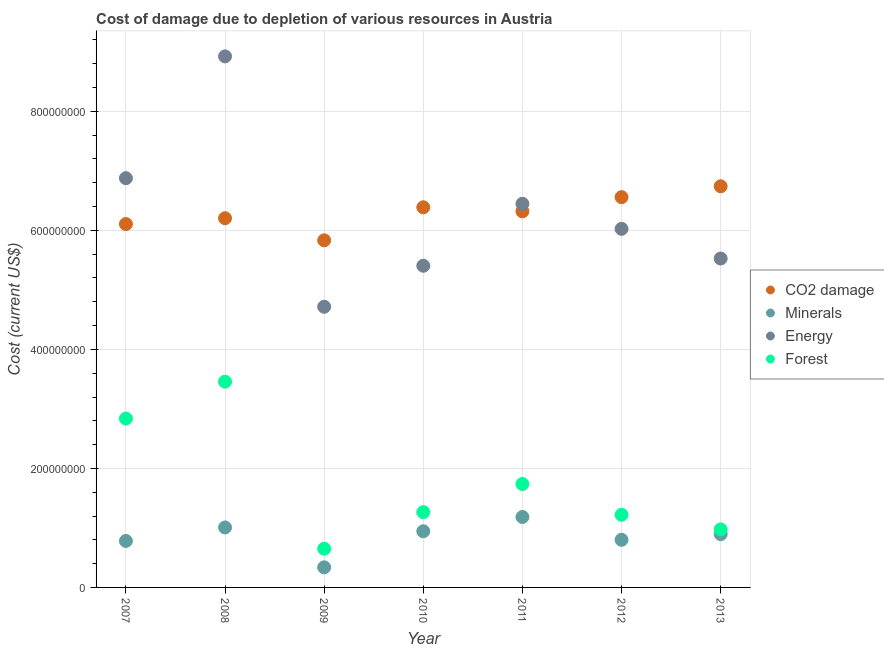What is the cost of damage due to depletion of energy in 2007?
Make the answer very short. 6.88e+08. Across all years, what is the maximum cost of damage due to depletion of minerals?
Your answer should be very brief. 1.18e+08. Across all years, what is the minimum cost of damage due to depletion of minerals?
Your answer should be very brief. 3.38e+07. What is the total cost of damage due to depletion of minerals in the graph?
Provide a short and direct response. 5.95e+08. What is the difference between the cost of damage due to depletion of energy in 2008 and that in 2009?
Provide a short and direct response. 4.21e+08. What is the difference between the cost of damage due to depletion of coal in 2011 and the cost of damage due to depletion of minerals in 2007?
Offer a very short reply. 5.54e+08. What is the average cost of damage due to depletion of minerals per year?
Give a very brief answer. 8.50e+07. In the year 2013, what is the difference between the cost of damage due to depletion of energy and cost of damage due to depletion of minerals?
Your answer should be very brief. 4.63e+08. In how many years, is the cost of damage due to depletion of coal greater than 160000000 US$?
Offer a very short reply. 7. What is the ratio of the cost of damage due to depletion of energy in 2007 to that in 2010?
Give a very brief answer. 1.27. What is the difference between the highest and the second highest cost of damage due to depletion of energy?
Your answer should be very brief. 2.05e+08. What is the difference between the highest and the lowest cost of damage due to depletion of forests?
Offer a terse response. 2.81e+08. In how many years, is the cost of damage due to depletion of coal greater than the average cost of damage due to depletion of coal taken over all years?
Give a very brief answer. 4. Is it the case that in every year, the sum of the cost of damage due to depletion of minerals and cost of damage due to depletion of energy is greater than the sum of cost of damage due to depletion of forests and cost of damage due to depletion of coal?
Give a very brief answer. Yes. Does the cost of damage due to depletion of minerals monotonically increase over the years?
Offer a terse response. No. Is the cost of damage due to depletion of forests strictly greater than the cost of damage due to depletion of minerals over the years?
Provide a short and direct response. Yes. Is the cost of damage due to depletion of coal strictly less than the cost of damage due to depletion of forests over the years?
Provide a short and direct response. No. How many dotlines are there?
Your answer should be very brief. 4. What is the difference between two consecutive major ticks on the Y-axis?
Keep it short and to the point. 2.00e+08. Does the graph contain grids?
Ensure brevity in your answer.  Yes. What is the title of the graph?
Your response must be concise. Cost of damage due to depletion of various resources in Austria . Does "Permanent crop land" appear as one of the legend labels in the graph?
Make the answer very short. No. What is the label or title of the X-axis?
Offer a terse response. Year. What is the label or title of the Y-axis?
Your response must be concise. Cost (current US$). What is the Cost (current US$) in CO2 damage in 2007?
Your answer should be compact. 6.11e+08. What is the Cost (current US$) in Minerals in 2007?
Make the answer very short. 7.81e+07. What is the Cost (current US$) in Energy in 2007?
Your answer should be very brief. 6.88e+08. What is the Cost (current US$) of Forest in 2007?
Give a very brief answer. 2.84e+08. What is the Cost (current US$) of CO2 damage in 2008?
Your answer should be very brief. 6.20e+08. What is the Cost (current US$) in Minerals in 2008?
Ensure brevity in your answer.  1.01e+08. What is the Cost (current US$) of Energy in 2008?
Ensure brevity in your answer.  8.92e+08. What is the Cost (current US$) in Forest in 2008?
Give a very brief answer. 3.46e+08. What is the Cost (current US$) in CO2 damage in 2009?
Give a very brief answer. 5.83e+08. What is the Cost (current US$) of Minerals in 2009?
Your answer should be compact. 3.38e+07. What is the Cost (current US$) in Energy in 2009?
Keep it short and to the point. 4.72e+08. What is the Cost (current US$) of Forest in 2009?
Your answer should be compact. 6.51e+07. What is the Cost (current US$) of CO2 damage in 2010?
Offer a very short reply. 6.39e+08. What is the Cost (current US$) of Minerals in 2010?
Your answer should be very brief. 9.44e+07. What is the Cost (current US$) of Energy in 2010?
Your answer should be very brief. 5.41e+08. What is the Cost (current US$) in Forest in 2010?
Keep it short and to the point. 1.27e+08. What is the Cost (current US$) of CO2 damage in 2011?
Provide a short and direct response. 6.32e+08. What is the Cost (current US$) in Minerals in 2011?
Offer a very short reply. 1.18e+08. What is the Cost (current US$) in Energy in 2011?
Provide a short and direct response. 6.45e+08. What is the Cost (current US$) of Forest in 2011?
Keep it short and to the point. 1.74e+08. What is the Cost (current US$) in CO2 damage in 2012?
Offer a very short reply. 6.56e+08. What is the Cost (current US$) in Minerals in 2012?
Keep it short and to the point. 8.00e+07. What is the Cost (current US$) of Energy in 2012?
Your answer should be compact. 6.03e+08. What is the Cost (current US$) of Forest in 2012?
Your answer should be compact. 1.22e+08. What is the Cost (current US$) in CO2 damage in 2013?
Make the answer very short. 6.74e+08. What is the Cost (current US$) of Minerals in 2013?
Your response must be concise. 8.96e+07. What is the Cost (current US$) in Energy in 2013?
Ensure brevity in your answer.  5.53e+08. What is the Cost (current US$) of Forest in 2013?
Keep it short and to the point. 9.76e+07. Across all years, what is the maximum Cost (current US$) in CO2 damage?
Give a very brief answer. 6.74e+08. Across all years, what is the maximum Cost (current US$) in Minerals?
Provide a short and direct response. 1.18e+08. Across all years, what is the maximum Cost (current US$) of Energy?
Your answer should be compact. 8.92e+08. Across all years, what is the maximum Cost (current US$) of Forest?
Provide a succinct answer. 3.46e+08. Across all years, what is the minimum Cost (current US$) in CO2 damage?
Your response must be concise. 5.83e+08. Across all years, what is the minimum Cost (current US$) of Minerals?
Provide a succinct answer. 3.38e+07. Across all years, what is the minimum Cost (current US$) in Energy?
Make the answer very short. 4.72e+08. Across all years, what is the minimum Cost (current US$) of Forest?
Provide a succinct answer. 6.51e+07. What is the total Cost (current US$) in CO2 damage in the graph?
Provide a short and direct response. 4.42e+09. What is the total Cost (current US$) of Minerals in the graph?
Offer a very short reply. 5.95e+08. What is the total Cost (current US$) of Energy in the graph?
Ensure brevity in your answer.  4.39e+09. What is the total Cost (current US$) of Forest in the graph?
Give a very brief answer. 1.21e+09. What is the difference between the Cost (current US$) in CO2 damage in 2007 and that in 2008?
Your answer should be very brief. -9.76e+06. What is the difference between the Cost (current US$) in Minerals in 2007 and that in 2008?
Make the answer very short. -2.27e+07. What is the difference between the Cost (current US$) of Energy in 2007 and that in 2008?
Give a very brief answer. -2.05e+08. What is the difference between the Cost (current US$) of Forest in 2007 and that in 2008?
Keep it short and to the point. -6.19e+07. What is the difference between the Cost (current US$) of CO2 damage in 2007 and that in 2009?
Provide a succinct answer. 2.74e+07. What is the difference between the Cost (current US$) in Minerals in 2007 and that in 2009?
Offer a terse response. 4.43e+07. What is the difference between the Cost (current US$) of Energy in 2007 and that in 2009?
Ensure brevity in your answer.  2.16e+08. What is the difference between the Cost (current US$) in Forest in 2007 and that in 2009?
Your answer should be compact. 2.19e+08. What is the difference between the Cost (current US$) in CO2 damage in 2007 and that in 2010?
Your answer should be compact. -2.82e+07. What is the difference between the Cost (current US$) of Minerals in 2007 and that in 2010?
Give a very brief answer. -1.63e+07. What is the difference between the Cost (current US$) in Energy in 2007 and that in 2010?
Ensure brevity in your answer.  1.47e+08. What is the difference between the Cost (current US$) in Forest in 2007 and that in 2010?
Provide a short and direct response. 1.57e+08. What is the difference between the Cost (current US$) in CO2 damage in 2007 and that in 2011?
Make the answer very short. -2.13e+07. What is the difference between the Cost (current US$) of Minerals in 2007 and that in 2011?
Offer a terse response. -4.03e+07. What is the difference between the Cost (current US$) in Energy in 2007 and that in 2011?
Your answer should be compact. 4.31e+07. What is the difference between the Cost (current US$) in Forest in 2007 and that in 2011?
Offer a very short reply. 1.10e+08. What is the difference between the Cost (current US$) in CO2 damage in 2007 and that in 2012?
Make the answer very short. -4.52e+07. What is the difference between the Cost (current US$) of Minerals in 2007 and that in 2012?
Ensure brevity in your answer.  -1.89e+06. What is the difference between the Cost (current US$) of Energy in 2007 and that in 2012?
Offer a very short reply. 8.51e+07. What is the difference between the Cost (current US$) of Forest in 2007 and that in 2012?
Offer a very short reply. 1.62e+08. What is the difference between the Cost (current US$) of CO2 damage in 2007 and that in 2013?
Your response must be concise. -6.35e+07. What is the difference between the Cost (current US$) of Minerals in 2007 and that in 2013?
Ensure brevity in your answer.  -1.14e+07. What is the difference between the Cost (current US$) of Energy in 2007 and that in 2013?
Your answer should be very brief. 1.35e+08. What is the difference between the Cost (current US$) in Forest in 2007 and that in 2013?
Make the answer very short. 1.86e+08. What is the difference between the Cost (current US$) of CO2 damage in 2008 and that in 2009?
Give a very brief answer. 3.71e+07. What is the difference between the Cost (current US$) of Minerals in 2008 and that in 2009?
Give a very brief answer. 6.70e+07. What is the difference between the Cost (current US$) of Energy in 2008 and that in 2009?
Give a very brief answer. 4.21e+08. What is the difference between the Cost (current US$) of Forest in 2008 and that in 2009?
Provide a succinct answer. 2.81e+08. What is the difference between the Cost (current US$) of CO2 damage in 2008 and that in 2010?
Your response must be concise. -1.84e+07. What is the difference between the Cost (current US$) in Minerals in 2008 and that in 2010?
Offer a terse response. 6.42e+06. What is the difference between the Cost (current US$) of Energy in 2008 and that in 2010?
Offer a terse response. 3.52e+08. What is the difference between the Cost (current US$) in Forest in 2008 and that in 2010?
Make the answer very short. 2.19e+08. What is the difference between the Cost (current US$) in CO2 damage in 2008 and that in 2011?
Your response must be concise. -1.16e+07. What is the difference between the Cost (current US$) in Minerals in 2008 and that in 2011?
Your answer should be very brief. -1.76e+07. What is the difference between the Cost (current US$) in Energy in 2008 and that in 2011?
Your response must be concise. 2.48e+08. What is the difference between the Cost (current US$) in Forest in 2008 and that in 2011?
Make the answer very short. 1.72e+08. What is the difference between the Cost (current US$) in CO2 damage in 2008 and that in 2012?
Provide a succinct answer. -3.54e+07. What is the difference between the Cost (current US$) of Minerals in 2008 and that in 2012?
Provide a succinct answer. 2.08e+07. What is the difference between the Cost (current US$) of Energy in 2008 and that in 2012?
Give a very brief answer. 2.90e+08. What is the difference between the Cost (current US$) of Forest in 2008 and that in 2012?
Give a very brief answer. 2.24e+08. What is the difference between the Cost (current US$) of CO2 damage in 2008 and that in 2013?
Your answer should be very brief. -5.38e+07. What is the difference between the Cost (current US$) in Minerals in 2008 and that in 2013?
Offer a terse response. 1.12e+07. What is the difference between the Cost (current US$) of Energy in 2008 and that in 2013?
Offer a very short reply. 3.40e+08. What is the difference between the Cost (current US$) of Forest in 2008 and that in 2013?
Keep it short and to the point. 2.48e+08. What is the difference between the Cost (current US$) in CO2 damage in 2009 and that in 2010?
Your answer should be very brief. -5.55e+07. What is the difference between the Cost (current US$) in Minerals in 2009 and that in 2010?
Make the answer very short. -6.06e+07. What is the difference between the Cost (current US$) in Energy in 2009 and that in 2010?
Your answer should be very brief. -6.89e+07. What is the difference between the Cost (current US$) in Forest in 2009 and that in 2010?
Provide a short and direct response. -6.14e+07. What is the difference between the Cost (current US$) of CO2 damage in 2009 and that in 2011?
Give a very brief answer. -4.87e+07. What is the difference between the Cost (current US$) in Minerals in 2009 and that in 2011?
Make the answer very short. -8.46e+07. What is the difference between the Cost (current US$) in Energy in 2009 and that in 2011?
Make the answer very short. -1.73e+08. What is the difference between the Cost (current US$) in Forest in 2009 and that in 2011?
Give a very brief answer. -1.09e+08. What is the difference between the Cost (current US$) of CO2 damage in 2009 and that in 2012?
Your answer should be compact. -7.26e+07. What is the difference between the Cost (current US$) of Minerals in 2009 and that in 2012?
Your answer should be very brief. -4.62e+07. What is the difference between the Cost (current US$) of Energy in 2009 and that in 2012?
Keep it short and to the point. -1.31e+08. What is the difference between the Cost (current US$) in Forest in 2009 and that in 2012?
Your answer should be very brief. -5.70e+07. What is the difference between the Cost (current US$) of CO2 damage in 2009 and that in 2013?
Offer a terse response. -9.09e+07. What is the difference between the Cost (current US$) in Minerals in 2009 and that in 2013?
Give a very brief answer. -5.58e+07. What is the difference between the Cost (current US$) in Energy in 2009 and that in 2013?
Make the answer very short. -8.10e+07. What is the difference between the Cost (current US$) in Forest in 2009 and that in 2013?
Your answer should be compact. -3.25e+07. What is the difference between the Cost (current US$) in CO2 damage in 2010 and that in 2011?
Ensure brevity in your answer.  6.82e+06. What is the difference between the Cost (current US$) in Minerals in 2010 and that in 2011?
Make the answer very short. -2.40e+07. What is the difference between the Cost (current US$) in Energy in 2010 and that in 2011?
Give a very brief answer. -1.04e+08. What is the difference between the Cost (current US$) of Forest in 2010 and that in 2011?
Give a very brief answer. -4.73e+07. What is the difference between the Cost (current US$) of CO2 damage in 2010 and that in 2012?
Your answer should be very brief. -1.70e+07. What is the difference between the Cost (current US$) of Minerals in 2010 and that in 2012?
Your answer should be very brief. 1.44e+07. What is the difference between the Cost (current US$) of Energy in 2010 and that in 2012?
Provide a succinct answer. -6.20e+07. What is the difference between the Cost (current US$) of Forest in 2010 and that in 2012?
Offer a terse response. 4.48e+06. What is the difference between the Cost (current US$) in CO2 damage in 2010 and that in 2013?
Keep it short and to the point. -3.53e+07. What is the difference between the Cost (current US$) of Minerals in 2010 and that in 2013?
Ensure brevity in your answer.  4.80e+06. What is the difference between the Cost (current US$) in Energy in 2010 and that in 2013?
Offer a very short reply. -1.21e+07. What is the difference between the Cost (current US$) of Forest in 2010 and that in 2013?
Provide a short and direct response. 2.90e+07. What is the difference between the Cost (current US$) of CO2 damage in 2011 and that in 2012?
Your answer should be very brief. -2.39e+07. What is the difference between the Cost (current US$) in Minerals in 2011 and that in 2012?
Provide a short and direct response. 3.84e+07. What is the difference between the Cost (current US$) of Energy in 2011 and that in 2012?
Your response must be concise. 4.21e+07. What is the difference between the Cost (current US$) of Forest in 2011 and that in 2012?
Your answer should be very brief. 5.17e+07. What is the difference between the Cost (current US$) of CO2 damage in 2011 and that in 2013?
Provide a short and direct response. -4.22e+07. What is the difference between the Cost (current US$) in Minerals in 2011 and that in 2013?
Ensure brevity in your answer.  2.88e+07. What is the difference between the Cost (current US$) of Energy in 2011 and that in 2013?
Ensure brevity in your answer.  9.20e+07. What is the difference between the Cost (current US$) of Forest in 2011 and that in 2013?
Give a very brief answer. 7.62e+07. What is the difference between the Cost (current US$) of CO2 damage in 2012 and that in 2013?
Make the answer very short. -1.83e+07. What is the difference between the Cost (current US$) in Minerals in 2012 and that in 2013?
Offer a very short reply. -9.55e+06. What is the difference between the Cost (current US$) in Energy in 2012 and that in 2013?
Your answer should be compact. 4.99e+07. What is the difference between the Cost (current US$) of Forest in 2012 and that in 2013?
Provide a succinct answer. 2.45e+07. What is the difference between the Cost (current US$) in CO2 damage in 2007 and the Cost (current US$) in Minerals in 2008?
Keep it short and to the point. 5.10e+08. What is the difference between the Cost (current US$) of CO2 damage in 2007 and the Cost (current US$) of Energy in 2008?
Your answer should be very brief. -2.82e+08. What is the difference between the Cost (current US$) in CO2 damage in 2007 and the Cost (current US$) in Forest in 2008?
Your response must be concise. 2.65e+08. What is the difference between the Cost (current US$) in Minerals in 2007 and the Cost (current US$) in Energy in 2008?
Keep it short and to the point. -8.14e+08. What is the difference between the Cost (current US$) of Minerals in 2007 and the Cost (current US$) of Forest in 2008?
Your response must be concise. -2.68e+08. What is the difference between the Cost (current US$) of Energy in 2007 and the Cost (current US$) of Forest in 2008?
Provide a short and direct response. 3.42e+08. What is the difference between the Cost (current US$) in CO2 damage in 2007 and the Cost (current US$) in Minerals in 2009?
Offer a terse response. 5.77e+08. What is the difference between the Cost (current US$) of CO2 damage in 2007 and the Cost (current US$) of Energy in 2009?
Your answer should be compact. 1.39e+08. What is the difference between the Cost (current US$) in CO2 damage in 2007 and the Cost (current US$) in Forest in 2009?
Offer a very short reply. 5.46e+08. What is the difference between the Cost (current US$) of Minerals in 2007 and the Cost (current US$) of Energy in 2009?
Keep it short and to the point. -3.94e+08. What is the difference between the Cost (current US$) of Minerals in 2007 and the Cost (current US$) of Forest in 2009?
Your answer should be very brief. 1.30e+07. What is the difference between the Cost (current US$) in Energy in 2007 and the Cost (current US$) in Forest in 2009?
Provide a succinct answer. 6.23e+08. What is the difference between the Cost (current US$) in CO2 damage in 2007 and the Cost (current US$) in Minerals in 2010?
Keep it short and to the point. 5.16e+08. What is the difference between the Cost (current US$) in CO2 damage in 2007 and the Cost (current US$) in Energy in 2010?
Keep it short and to the point. 7.01e+07. What is the difference between the Cost (current US$) of CO2 damage in 2007 and the Cost (current US$) of Forest in 2010?
Your response must be concise. 4.84e+08. What is the difference between the Cost (current US$) of Minerals in 2007 and the Cost (current US$) of Energy in 2010?
Provide a short and direct response. -4.62e+08. What is the difference between the Cost (current US$) in Minerals in 2007 and the Cost (current US$) in Forest in 2010?
Make the answer very short. -4.84e+07. What is the difference between the Cost (current US$) in Energy in 2007 and the Cost (current US$) in Forest in 2010?
Provide a succinct answer. 5.61e+08. What is the difference between the Cost (current US$) of CO2 damage in 2007 and the Cost (current US$) of Minerals in 2011?
Your answer should be very brief. 4.92e+08. What is the difference between the Cost (current US$) in CO2 damage in 2007 and the Cost (current US$) in Energy in 2011?
Your answer should be very brief. -3.40e+07. What is the difference between the Cost (current US$) in CO2 damage in 2007 and the Cost (current US$) in Forest in 2011?
Offer a terse response. 4.37e+08. What is the difference between the Cost (current US$) in Minerals in 2007 and the Cost (current US$) in Energy in 2011?
Your answer should be compact. -5.67e+08. What is the difference between the Cost (current US$) of Minerals in 2007 and the Cost (current US$) of Forest in 2011?
Your answer should be very brief. -9.57e+07. What is the difference between the Cost (current US$) of Energy in 2007 and the Cost (current US$) of Forest in 2011?
Ensure brevity in your answer.  5.14e+08. What is the difference between the Cost (current US$) in CO2 damage in 2007 and the Cost (current US$) in Minerals in 2012?
Keep it short and to the point. 5.31e+08. What is the difference between the Cost (current US$) in CO2 damage in 2007 and the Cost (current US$) in Energy in 2012?
Provide a short and direct response. 8.07e+06. What is the difference between the Cost (current US$) of CO2 damage in 2007 and the Cost (current US$) of Forest in 2012?
Provide a short and direct response. 4.89e+08. What is the difference between the Cost (current US$) in Minerals in 2007 and the Cost (current US$) in Energy in 2012?
Keep it short and to the point. -5.24e+08. What is the difference between the Cost (current US$) of Minerals in 2007 and the Cost (current US$) of Forest in 2012?
Offer a very short reply. -4.39e+07. What is the difference between the Cost (current US$) of Energy in 2007 and the Cost (current US$) of Forest in 2012?
Your answer should be compact. 5.66e+08. What is the difference between the Cost (current US$) in CO2 damage in 2007 and the Cost (current US$) in Minerals in 2013?
Provide a succinct answer. 5.21e+08. What is the difference between the Cost (current US$) in CO2 damage in 2007 and the Cost (current US$) in Energy in 2013?
Provide a succinct answer. 5.80e+07. What is the difference between the Cost (current US$) in CO2 damage in 2007 and the Cost (current US$) in Forest in 2013?
Make the answer very short. 5.13e+08. What is the difference between the Cost (current US$) of Minerals in 2007 and the Cost (current US$) of Energy in 2013?
Ensure brevity in your answer.  -4.75e+08. What is the difference between the Cost (current US$) of Minerals in 2007 and the Cost (current US$) of Forest in 2013?
Make the answer very short. -1.94e+07. What is the difference between the Cost (current US$) of Energy in 2007 and the Cost (current US$) of Forest in 2013?
Give a very brief answer. 5.90e+08. What is the difference between the Cost (current US$) of CO2 damage in 2008 and the Cost (current US$) of Minerals in 2009?
Provide a short and direct response. 5.87e+08. What is the difference between the Cost (current US$) in CO2 damage in 2008 and the Cost (current US$) in Energy in 2009?
Your answer should be compact. 1.49e+08. What is the difference between the Cost (current US$) in CO2 damage in 2008 and the Cost (current US$) in Forest in 2009?
Your answer should be compact. 5.55e+08. What is the difference between the Cost (current US$) in Minerals in 2008 and the Cost (current US$) in Energy in 2009?
Your response must be concise. -3.71e+08. What is the difference between the Cost (current US$) of Minerals in 2008 and the Cost (current US$) of Forest in 2009?
Offer a terse response. 3.57e+07. What is the difference between the Cost (current US$) in Energy in 2008 and the Cost (current US$) in Forest in 2009?
Ensure brevity in your answer.  8.27e+08. What is the difference between the Cost (current US$) of CO2 damage in 2008 and the Cost (current US$) of Minerals in 2010?
Provide a short and direct response. 5.26e+08. What is the difference between the Cost (current US$) of CO2 damage in 2008 and the Cost (current US$) of Energy in 2010?
Provide a short and direct response. 7.99e+07. What is the difference between the Cost (current US$) of CO2 damage in 2008 and the Cost (current US$) of Forest in 2010?
Keep it short and to the point. 4.94e+08. What is the difference between the Cost (current US$) in Minerals in 2008 and the Cost (current US$) in Energy in 2010?
Make the answer very short. -4.40e+08. What is the difference between the Cost (current US$) of Minerals in 2008 and the Cost (current US$) of Forest in 2010?
Provide a succinct answer. -2.57e+07. What is the difference between the Cost (current US$) of Energy in 2008 and the Cost (current US$) of Forest in 2010?
Provide a succinct answer. 7.66e+08. What is the difference between the Cost (current US$) in CO2 damage in 2008 and the Cost (current US$) in Minerals in 2011?
Provide a succinct answer. 5.02e+08. What is the difference between the Cost (current US$) in CO2 damage in 2008 and the Cost (current US$) in Energy in 2011?
Ensure brevity in your answer.  -2.42e+07. What is the difference between the Cost (current US$) of CO2 damage in 2008 and the Cost (current US$) of Forest in 2011?
Make the answer very short. 4.47e+08. What is the difference between the Cost (current US$) in Minerals in 2008 and the Cost (current US$) in Energy in 2011?
Ensure brevity in your answer.  -5.44e+08. What is the difference between the Cost (current US$) in Minerals in 2008 and the Cost (current US$) in Forest in 2011?
Give a very brief answer. -7.30e+07. What is the difference between the Cost (current US$) in Energy in 2008 and the Cost (current US$) in Forest in 2011?
Offer a terse response. 7.19e+08. What is the difference between the Cost (current US$) in CO2 damage in 2008 and the Cost (current US$) in Minerals in 2012?
Your answer should be very brief. 5.40e+08. What is the difference between the Cost (current US$) of CO2 damage in 2008 and the Cost (current US$) of Energy in 2012?
Your response must be concise. 1.78e+07. What is the difference between the Cost (current US$) of CO2 damage in 2008 and the Cost (current US$) of Forest in 2012?
Provide a succinct answer. 4.98e+08. What is the difference between the Cost (current US$) in Minerals in 2008 and the Cost (current US$) in Energy in 2012?
Your answer should be compact. -5.02e+08. What is the difference between the Cost (current US$) of Minerals in 2008 and the Cost (current US$) of Forest in 2012?
Give a very brief answer. -2.13e+07. What is the difference between the Cost (current US$) in Energy in 2008 and the Cost (current US$) in Forest in 2012?
Provide a succinct answer. 7.70e+08. What is the difference between the Cost (current US$) in CO2 damage in 2008 and the Cost (current US$) in Minerals in 2013?
Provide a short and direct response. 5.31e+08. What is the difference between the Cost (current US$) of CO2 damage in 2008 and the Cost (current US$) of Energy in 2013?
Offer a very short reply. 6.77e+07. What is the difference between the Cost (current US$) in CO2 damage in 2008 and the Cost (current US$) in Forest in 2013?
Your answer should be very brief. 5.23e+08. What is the difference between the Cost (current US$) of Minerals in 2008 and the Cost (current US$) of Energy in 2013?
Offer a terse response. -4.52e+08. What is the difference between the Cost (current US$) of Minerals in 2008 and the Cost (current US$) of Forest in 2013?
Make the answer very short. 3.23e+06. What is the difference between the Cost (current US$) of Energy in 2008 and the Cost (current US$) of Forest in 2013?
Make the answer very short. 7.95e+08. What is the difference between the Cost (current US$) of CO2 damage in 2009 and the Cost (current US$) of Minerals in 2010?
Your response must be concise. 4.89e+08. What is the difference between the Cost (current US$) in CO2 damage in 2009 and the Cost (current US$) in Energy in 2010?
Ensure brevity in your answer.  4.27e+07. What is the difference between the Cost (current US$) in CO2 damage in 2009 and the Cost (current US$) in Forest in 2010?
Offer a terse response. 4.57e+08. What is the difference between the Cost (current US$) in Minerals in 2009 and the Cost (current US$) in Energy in 2010?
Provide a succinct answer. -5.07e+08. What is the difference between the Cost (current US$) of Minerals in 2009 and the Cost (current US$) of Forest in 2010?
Keep it short and to the point. -9.28e+07. What is the difference between the Cost (current US$) of Energy in 2009 and the Cost (current US$) of Forest in 2010?
Your answer should be very brief. 3.45e+08. What is the difference between the Cost (current US$) in CO2 damage in 2009 and the Cost (current US$) in Minerals in 2011?
Provide a succinct answer. 4.65e+08. What is the difference between the Cost (current US$) of CO2 damage in 2009 and the Cost (current US$) of Energy in 2011?
Your answer should be very brief. -6.14e+07. What is the difference between the Cost (current US$) in CO2 damage in 2009 and the Cost (current US$) in Forest in 2011?
Make the answer very short. 4.09e+08. What is the difference between the Cost (current US$) of Minerals in 2009 and the Cost (current US$) of Energy in 2011?
Give a very brief answer. -6.11e+08. What is the difference between the Cost (current US$) in Minerals in 2009 and the Cost (current US$) in Forest in 2011?
Your answer should be very brief. -1.40e+08. What is the difference between the Cost (current US$) in Energy in 2009 and the Cost (current US$) in Forest in 2011?
Offer a very short reply. 2.98e+08. What is the difference between the Cost (current US$) in CO2 damage in 2009 and the Cost (current US$) in Minerals in 2012?
Provide a short and direct response. 5.03e+08. What is the difference between the Cost (current US$) in CO2 damage in 2009 and the Cost (current US$) in Energy in 2012?
Keep it short and to the point. -1.93e+07. What is the difference between the Cost (current US$) in CO2 damage in 2009 and the Cost (current US$) in Forest in 2012?
Keep it short and to the point. 4.61e+08. What is the difference between the Cost (current US$) of Minerals in 2009 and the Cost (current US$) of Energy in 2012?
Make the answer very short. -5.69e+08. What is the difference between the Cost (current US$) in Minerals in 2009 and the Cost (current US$) in Forest in 2012?
Your answer should be compact. -8.83e+07. What is the difference between the Cost (current US$) in Energy in 2009 and the Cost (current US$) in Forest in 2012?
Keep it short and to the point. 3.50e+08. What is the difference between the Cost (current US$) in CO2 damage in 2009 and the Cost (current US$) in Minerals in 2013?
Keep it short and to the point. 4.94e+08. What is the difference between the Cost (current US$) of CO2 damage in 2009 and the Cost (current US$) of Energy in 2013?
Provide a succinct answer. 3.06e+07. What is the difference between the Cost (current US$) of CO2 damage in 2009 and the Cost (current US$) of Forest in 2013?
Offer a terse response. 4.86e+08. What is the difference between the Cost (current US$) in Minerals in 2009 and the Cost (current US$) in Energy in 2013?
Your answer should be compact. -5.19e+08. What is the difference between the Cost (current US$) in Minerals in 2009 and the Cost (current US$) in Forest in 2013?
Ensure brevity in your answer.  -6.38e+07. What is the difference between the Cost (current US$) of Energy in 2009 and the Cost (current US$) of Forest in 2013?
Your answer should be compact. 3.74e+08. What is the difference between the Cost (current US$) of CO2 damage in 2010 and the Cost (current US$) of Minerals in 2011?
Provide a succinct answer. 5.20e+08. What is the difference between the Cost (current US$) of CO2 damage in 2010 and the Cost (current US$) of Energy in 2011?
Your answer should be compact. -5.82e+06. What is the difference between the Cost (current US$) of CO2 damage in 2010 and the Cost (current US$) of Forest in 2011?
Provide a succinct answer. 4.65e+08. What is the difference between the Cost (current US$) in Minerals in 2010 and the Cost (current US$) in Energy in 2011?
Offer a terse response. -5.50e+08. What is the difference between the Cost (current US$) of Minerals in 2010 and the Cost (current US$) of Forest in 2011?
Make the answer very short. -7.94e+07. What is the difference between the Cost (current US$) in Energy in 2010 and the Cost (current US$) in Forest in 2011?
Offer a terse response. 3.67e+08. What is the difference between the Cost (current US$) in CO2 damage in 2010 and the Cost (current US$) in Minerals in 2012?
Provide a succinct answer. 5.59e+08. What is the difference between the Cost (current US$) in CO2 damage in 2010 and the Cost (current US$) in Energy in 2012?
Your response must be concise. 3.62e+07. What is the difference between the Cost (current US$) of CO2 damage in 2010 and the Cost (current US$) of Forest in 2012?
Offer a very short reply. 5.17e+08. What is the difference between the Cost (current US$) of Minerals in 2010 and the Cost (current US$) of Energy in 2012?
Offer a very short reply. -5.08e+08. What is the difference between the Cost (current US$) in Minerals in 2010 and the Cost (current US$) in Forest in 2012?
Give a very brief answer. -2.77e+07. What is the difference between the Cost (current US$) in Energy in 2010 and the Cost (current US$) in Forest in 2012?
Keep it short and to the point. 4.18e+08. What is the difference between the Cost (current US$) of CO2 damage in 2010 and the Cost (current US$) of Minerals in 2013?
Your response must be concise. 5.49e+08. What is the difference between the Cost (current US$) of CO2 damage in 2010 and the Cost (current US$) of Energy in 2013?
Keep it short and to the point. 8.61e+07. What is the difference between the Cost (current US$) in CO2 damage in 2010 and the Cost (current US$) in Forest in 2013?
Your response must be concise. 5.41e+08. What is the difference between the Cost (current US$) of Minerals in 2010 and the Cost (current US$) of Energy in 2013?
Ensure brevity in your answer.  -4.58e+08. What is the difference between the Cost (current US$) in Minerals in 2010 and the Cost (current US$) in Forest in 2013?
Ensure brevity in your answer.  -3.19e+06. What is the difference between the Cost (current US$) of Energy in 2010 and the Cost (current US$) of Forest in 2013?
Your answer should be compact. 4.43e+08. What is the difference between the Cost (current US$) of CO2 damage in 2011 and the Cost (current US$) of Minerals in 2012?
Ensure brevity in your answer.  5.52e+08. What is the difference between the Cost (current US$) of CO2 damage in 2011 and the Cost (current US$) of Energy in 2012?
Provide a succinct answer. 2.94e+07. What is the difference between the Cost (current US$) in CO2 damage in 2011 and the Cost (current US$) in Forest in 2012?
Keep it short and to the point. 5.10e+08. What is the difference between the Cost (current US$) in Minerals in 2011 and the Cost (current US$) in Energy in 2012?
Offer a terse response. -4.84e+08. What is the difference between the Cost (current US$) of Minerals in 2011 and the Cost (current US$) of Forest in 2012?
Your response must be concise. -3.65e+06. What is the difference between the Cost (current US$) in Energy in 2011 and the Cost (current US$) in Forest in 2012?
Give a very brief answer. 5.23e+08. What is the difference between the Cost (current US$) of CO2 damage in 2011 and the Cost (current US$) of Minerals in 2013?
Provide a short and direct response. 5.42e+08. What is the difference between the Cost (current US$) in CO2 damage in 2011 and the Cost (current US$) in Energy in 2013?
Make the answer very short. 7.93e+07. What is the difference between the Cost (current US$) in CO2 damage in 2011 and the Cost (current US$) in Forest in 2013?
Offer a very short reply. 5.34e+08. What is the difference between the Cost (current US$) of Minerals in 2011 and the Cost (current US$) of Energy in 2013?
Your response must be concise. -4.34e+08. What is the difference between the Cost (current US$) in Minerals in 2011 and the Cost (current US$) in Forest in 2013?
Your answer should be very brief. 2.08e+07. What is the difference between the Cost (current US$) of Energy in 2011 and the Cost (current US$) of Forest in 2013?
Ensure brevity in your answer.  5.47e+08. What is the difference between the Cost (current US$) of CO2 damage in 2012 and the Cost (current US$) of Minerals in 2013?
Give a very brief answer. 5.66e+08. What is the difference between the Cost (current US$) in CO2 damage in 2012 and the Cost (current US$) in Energy in 2013?
Your answer should be compact. 1.03e+08. What is the difference between the Cost (current US$) of CO2 damage in 2012 and the Cost (current US$) of Forest in 2013?
Your answer should be very brief. 5.58e+08. What is the difference between the Cost (current US$) of Minerals in 2012 and the Cost (current US$) of Energy in 2013?
Provide a succinct answer. -4.73e+08. What is the difference between the Cost (current US$) of Minerals in 2012 and the Cost (current US$) of Forest in 2013?
Your response must be concise. -1.75e+07. What is the difference between the Cost (current US$) in Energy in 2012 and the Cost (current US$) in Forest in 2013?
Give a very brief answer. 5.05e+08. What is the average Cost (current US$) of CO2 damage per year?
Offer a terse response. 6.31e+08. What is the average Cost (current US$) in Minerals per year?
Keep it short and to the point. 8.50e+07. What is the average Cost (current US$) of Energy per year?
Your response must be concise. 6.27e+08. What is the average Cost (current US$) of Forest per year?
Your response must be concise. 1.74e+08. In the year 2007, what is the difference between the Cost (current US$) in CO2 damage and Cost (current US$) in Minerals?
Give a very brief answer. 5.33e+08. In the year 2007, what is the difference between the Cost (current US$) of CO2 damage and Cost (current US$) of Energy?
Offer a terse response. -7.70e+07. In the year 2007, what is the difference between the Cost (current US$) in CO2 damage and Cost (current US$) in Forest?
Keep it short and to the point. 3.27e+08. In the year 2007, what is the difference between the Cost (current US$) in Minerals and Cost (current US$) in Energy?
Offer a terse response. -6.10e+08. In the year 2007, what is the difference between the Cost (current US$) in Minerals and Cost (current US$) in Forest?
Offer a very short reply. -2.06e+08. In the year 2007, what is the difference between the Cost (current US$) in Energy and Cost (current US$) in Forest?
Provide a succinct answer. 4.04e+08. In the year 2008, what is the difference between the Cost (current US$) in CO2 damage and Cost (current US$) in Minerals?
Offer a terse response. 5.20e+08. In the year 2008, what is the difference between the Cost (current US$) of CO2 damage and Cost (current US$) of Energy?
Give a very brief answer. -2.72e+08. In the year 2008, what is the difference between the Cost (current US$) in CO2 damage and Cost (current US$) in Forest?
Offer a terse response. 2.75e+08. In the year 2008, what is the difference between the Cost (current US$) in Minerals and Cost (current US$) in Energy?
Your answer should be very brief. -7.92e+08. In the year 2008, what is the difference between the Cost (current US$) of Minerals and Cost (current US$) of Forest?
Your answer should be compact. -2.45e+08. In the year 2008, what is the difference between the Cost (current US$) of Energy and Cost (current US$) of Forest?
Offer a terse response. 5.47e+08. In the year 2009, what is the difference between the Cost (current US$) in CO2 damage and Cost (current US$) in Minerals?
Give a very brief answer. 5.50e+08. In the year 2009, what is the difference between the Cost (current US$) of CO2 damage and Cost (current US$) of Energy?
Offer a terse response. 1.12e+08. In the year 2009, what is the difference between the Cost (current US$) of CO2 damage and Cost (current US$) of Forest?
Ensure brevity in your answer.  5.18e+08. In the year 2009, what is the difference between the Cost (current US$) of Minerals and Cost (current US$) of Energy?
Keep it short and to the point. -4.38e+08. In the year 2009, what is the difference between the Cost (current US$) of Minerals and Cost (current US$) of Forest?
Give a very brief answer. -3.13e+07. In the year 2009, what is the difference between the Cost (current US$) in Energy and Cost (current US$) in Forest?
Your response must be concise. 4.07e+08. In the year 2010, what is the difference between the Cost (current US$) of CO2 damage and Cost (current US$) of Minerals?
Offer a terse response. 5.44e+08. In the year 2010, what is the difference between the Cost (current US$) in CO2 damage and Cost (current US$) in Energy?
Your answer should be compact. 9.83e+07. In the year 2010, what is the difference between the Cost (current US$) in CO2 damage and Cost (current US$) in Forest?
Keep it short and to the point. 5.12e+08. In the year 2010, what is the difference between the Cost (current US$) in Minerals and Cost (current US$) in Energy?
Your answer should be very brief. -4.46e+08. In the year 2010, what is the difference between the Cost (current US$) of Minerals and Cost (current US$) of Forest?
Your response must be concise. -3.22e+07. In the year 2010, what is the difference between the Cost (current US$) of Energy and Cost (current US$) of Forest?
Keep it short and to the point. 4.14e+08. In the year 2011, what is the difference between the Cost (current US$) in CO2 damage and Cost (current US$) in Minerals?
Make the answer very short. 5.14e+08. In the year 2011, what is the difference between the Cost (current US$) of CO2 damage and Cost (current US$) of Energy?
Make the answer very short. -1.26e+07. In the year 2011, what is the difference between the Cost (current US$) of CO2 damage and Cost (current US$) of Forest?
Keep it short and to the point. 4.58e+08. In the year 2011, what is the difference between the Cost (current US$) of Minerals and Cost (current US$) of Energy?
Offer a very short reply. -5.26e+08. In the year 2011, what is the difference between the Cost (current US$) of Minerals and Cost (current US$) of Forest?
Provide a succinct answer. -5.54e+07. In the year 2011, what is the difference between the Cost (current US$) of Energy and Cost (current US$) of Forest?
Give a very brief answer. 4.71e+08. In the year 2012, what is the difference between the Cost (current US$) in CO2 damage and Cost (current US$) in Minerals?
Your response must be concise. 5.76e+08. In the year 2012, what is the difference between the Cost (current US$) in CO2 damage and Cost (current US$) in Energy?
Provide a short and direct response. 5.33e+07. In the year 2012, what is the difference between the Cost (current US$) in CO2 damage and Cost (current US$) in Forest?
Provide a succinct answer. 5.34e+08. In the year 2012, what is the difference between the Cost (current US$) of Minerals and Cost (current US$) of Energy?
Keep it short and to the point. -5.23e+08. In the year 2012, what is the difference between the Cost (current US$) in Minerals and Cost (current US$) in Forest?
Offer a very short reply. -4.20e+07. In the year 2012, what is the difference between the Cost (current US$) of Energy and Cost (current US$) of Forest?
Your response must be concise. 4.81e+08. In the year 2013, what is the difference between the Cost (current US$) of CO2 damage and Cost (current US$) of Minerals?
Offer a terse response. 5.85e+08. In the year 2013, what is the difference between the Cost (current US$) in CO2 damage and Cost (current US$) in Energy?
Offer a terse response. 1.21e+08. In the year 2013, what is the difference between the Cost (current US$) in CO2 damage and Cost (current US$) in Forest?
Your response must be concise. 5.77e+08. In the year 2013, what is the difference between the Cost (current US$) in Minerals and Cost (current US$) in Energy?
Your answer should be very brief. -4.63e+08. In the year 2013, what is the difference between the Cost (current US$) of Minerals and Cost (current US$) of Forest?
Make the answer very short. -7.99e+06. In the year 2013, what is the difference between the Cost (current US$) of Energy and Cost (current US$) of Forest?
Ensure brevity in your answer.  4.55e+08. What is the ratio of the Cost (current US$) of CO2 damage in 2007 to that in 2008?
Ensure brevity in your answer.  0.98. What is the ratio of the Cost (current US$) in Minerals in 2007 to that in 2008?
Provide a succinct answer. 0.78. What is the ratio of the Cost (current US$) of Energy in 2007 to that in 2008?
Provide a succinct answer. 0.77. What is the ratio of the Cost (current US$) of Forest in 2007 to that in 2008?
Keep it short and to the point. 0.82. What is the ratio of the Cost (current US$) in CO2 damage in 2007 to that in 2009?
Your answer should be compact. 1.05. What is the ratio of the Cost (current US$) of Minerals in 2007 to that in 2009?
Your response must be concise. 2.31. What is the ratio of the Cost (current US$) in Energy in 2007 to that in 2009?
Give a very brief answer. 1.46. What is the ratio of the Cost (current US$) in Forest in 2007 to that in 2009?
Your answer should be compact. 4.36. What is the ratio of the Cost (current US$) of CO2 damage in 2007 to that in 2010?
Your answer should be very brief. 0.96. What is the ratio of the Cost (current US$) of Minerals in 2007 to that in 2010?
Provide a succinct answer. 0.83. What is the ratio of the Cost (current US$) in Energy in 2007 to that in 2010?
Provide a short and direct response. 1.27. What is the ratio of the Cost (current US$) in Forest in 2007 to that in 2010?
Your response must be concise. 2.24. What is the ratio of the Cost (current US$) in CO2 damage in 2007 to that in 2011?
Your answer should be very brief. 0.97. What is the ratio of the Cost (current US$) in Minerals in 2007 to that in 2011?
Your answer should be very brief. 0.66. What is the ratio of the Cost (current US$) of Energy in 2007 to that in 2011?
Ensure brevity in your answer.  1.07. What is the ratio of the Cost (current US$) in Forest in 2007 to that in 2011?
Your answer should be compact. 1.63. What is the ratio of the Cost (current US$) in CO2 damage in 2007 to that in 2012?
Give a very brief answer. 0.93. What is the ratio of the Cost (current US$) in Minerals in 2007 to that in 2012?
Your answer should be compact. 0.98. What is the ratio of the Cost (current US$) in Energy in 2007 to that in 2012?
Offer a very short reply. 1.14. What is the ratio of the Cost (current US$) of Forest in 2007 to that in 2012?
Keep it short and to the point. 2.33. What is the ratio of the Cost (current US$) of CO2 damage in 2007 to that in 2013?
Offer a very short reply. 0.91. What is the ratio of the Cost (current US$) of Minerals in 2007 to that in 2013?
Your answer should be very brief. 0.87. What is the ratio of the Cost (current US$) of Energy in 2007 to that in 2013?
Offer a very short reply. 1.24. What is the ratio of the Cost (current US$) in Forest in 2007 to that in 2013?
Your answer should be compact. 2.91. What is the ratio of the Cost (current US$) of CO2 damage in 2008 to that in 2009?
Ensure brevity in your answer.  1.06. What is the ratio of the Cost (current US$) of Minerals in 2008 to that in 2009?
Give a very brief answer. 2.98. What is the ratio of the Cost (current US$) of Energy in 2008 to that in 2009?
Provide a short and direct response. 1.89. What is the ratio of the Cost (current US$) of Forest in 2008 to that in 2009?
Your response must be concise. 5.31. What is the ratio of the Cost (current US$) of CO2 damage in 2008 to that in 2010?
Keep it short and to the point. 0.97. What is the ratio of the Cost (current US$) of Minerals in 2008 to that in 2010?
Your response must be concise. 1.07. What is the ratio of the Cost (current US$) of Energy in 2008 to that in 2010?
Provide a succinct answer. 1.65. What is the ratio of the Cost (current US$) in Forest in 2008 to that in 2010?
Provide a short and direct response. 2.73. What is the ratio of the Cost (current US$) of CO2 damage in 2008 to that in 2011?
Offer a very short reply. 0.98. What is the ratio of the Cost (current US$) of Minerals in 2008 to that in 2011?
Offer a very short reply. 0.85. What is the ratio of the Cost (current US$) in Energy in 2008 to that in 2011?
Your answer should be very brief. 1.38. What is the ratio of the Cost (current US$) of Forest in 2008 to that in 2011?
Offer a very short reply. 1.99. What is the ratio of the Cost (current US$) in CO2 damage in 2008 to that in 2012?
Offer a very short reply. 0.95. What is the ratio of the Cost (current US$) in Minerals in 2008 to that in 2012?
Your answer should be compact. 1.26. What is the ratio of the Cost (current US$) in Energy in 2008 to that in 2012?
Give a very brief answer. 1.48. What is the ratio of the Cost (current US$) of Forest in 2008 to that in 2012?
Give a very brief answer. 2.83. What is the ratio of the Cost (current US$) in CO2 damage in 2008 to that in 2013?
Provide a short and direct response. 0.92. What is the ratio of the Cost (current US$) in Minerals in 2008 to that in 2013?
Give a very brief answer. 1.13. What is the ratio of the Cost (current US$) in Energy in 2008 to that in 2013?
Your answer should be compact. 1.61. What is the ratio of the Cost (current US$) of Forest in 2008 to that in 2013?
Ensure brevity in your answer.  3.54. What is the ratio of the Cost (current US$) in CO2 damage in 2009 to that in 2010?
Provide a short and direct response. 0.91. What is the ratio of the Cost (current US$) in Minerals in 2009 to that in 2010?
Offer a terse response. 0.36. What is the ratio of the Cost (current US$) of Energy in 2009 to that in 2010?
Your response must be concise. 0.87. What is the ratio of the Cost (current US$) of Forest in 2009 to that in 2010?
Provide a short and direct response. 0.51. What is the ratio of the Cost (current US$) of CO2 damage in 2009 to that in 2011?
Your answer should be compact. 0.92. What is the ratio of the Cost (current US$) of Minerals in 2009 to that in 2011?
Make the answer very short. 0.29. What is the ratio of the Cost (current US$) in Energy in 2009 to that in 2011?
Provide a short and direct response. 0.73. What is the ratio of the Cost (current US$) in Forest in 2009 to that in 2011?
Your response must be concise. 0.37. What is the ratio of the Cost (current US$) of CO2 damage in 2009 to that in 2012?
Provide a succinct answer. 0.89. What is the ratio of the Cost (current US$) in Minerals in 2009 to that in 2012?
Provide a succinct answer. 0.42. What is the ratio of the Cost (current US$) in Energy in 2009 to that in 2012?
Give a very brief answer. 0.78. What is the ratio of the Cost (current US$) in Forest in 2009 to that in 2012?
Your response must be concise. 0.53. What is the ratio of the Cost (current US$) of CO2 damage in 2009 to that in 2013?
Make the answer very short. 0.87. What is the ratio of the Cost (current US$) of Minerals in 2009 to that in 2013?
Your response must be concise. 0.38. What is the ratio of the Cost (current US$) of Energy in 2009 to that in 2013?
Make the answer very short. 0.85. What is the ratio of the Cost (current US$) of Forest in 2009 to that in 2013?
Provide a short and direct response. 0.67. What is the ratio of the Cost (current US$) of CO2 damage in 2010 to that in 2011?
Ensure brevity in your answer.  1.01. What is the ratio of the Cost (current US$) of Minerals in 2010 to that in 2011?
Make the answer very short. 0.8. What is the ratio of the Cost (current US$) of Energy in 2010 to that in 2011?
Offer a terse response. 0.84. What is the ratio of the Cost (current US$) of Forest in 2010 to that in 2011?
Your response must be concise. 0.73. What is the ratio of the Cost (current US$) of CO2 damage in 2010 to that in 2012?
Your response must be concise. 0.97. What is the ratio of the Cost (current US$) of Minerals in 2010 to that in 2012?
Give a very brief answer. 1.18. What is the ratio of the Cost (current US$) of Energy in 2010 to that in 2012?
Your answer should be compact. 0.9. What is the ratio of the Cost (current US$) in Forest in 2010 to that in 2012?
Provide a succinct answer. 1.04. What is the ratio of the Cost (current US$) in CO2 damage in 2010 to that in 2013?
Your response must be concise. 0.95. What is the ratio of the Cost (current US$) of Minerals in 2010 to that in 2013?
Your answer should be compact. 1.05. What is the ratio of the Cost (current US$) in Energy in 2010 to that in 2013?
Your answer should be very brief. 0.98. What is the ratio of the Cost (current US$) in Forest in 2010 to that in 2013?
Provide a short and direct response. 1.3. What is the ratio of the Cost (current US$) in CO2 damage in 2011 to that in 2012?
Make the answer very short. 0.96. What is the ratio of the Cost (current US$) of Minerals in 2011 to that in 2012?
Offer a terse response. 1.48. What is the ratio of the Cost (current US$) in Energy in 2011 to that in 2012?
Offer a terse response. 1.07. What is the ratio of the Cost (current US$) in Forest in 2011 to that in 2012?
Offer a very short reply. 1.42. What is the ratio of the Cost (current US$) in Minerals in 2011 to that in 2013?
Keep it short and to the point. 1.32. What is the ratio of the Cost (current US$) of Energy in 2011 to that in 2013?
Offer a terse response. 1.17. What is the ratio of the Cost (current US$) in Forest in 2011 to that in 2013?
Provide a short and direct response. 1.78. What is the ratio of the Cost (current US$) in CO2 damage in 2012 to that in 2013?
Your response must be concise. 0.97. What is the ratio of the Cost (current US$) in Minerals in 2012 to that in 2013?
Provide a succinct answer. 0.89. What is the ratio of the Cost (current US$) in Energy in 2012 to that in 2013?
Provide a succinct answer. 1.09. What is the ratio of the Cost (current US$) in Forest in 2012 to that in 2013?
Make the answer very short. 1.25. What is the difference between the highest and the second highest Cost (current US$) of CO2 damage?
Offer a very short reply. 1.83e+07. What is the difference between the highest and the second highest Cost (current US$) in Minerals?
Offer a terse response. 1.76e+07. What is the difference between the highest and the second highest Cost (current US$) of Energy?
Offer a very short reply. 2.05e+08. What is the difference between the highest and the second highest Cost (current US$) in Forest?
Ensure brevity in your answer.  6.19e+07. What is the difference between the highest and the lowest Cost (current US$) of CO2 damage?
Make the answer very short. 9.09e+07. What is the difference between the highest and the lowest Cost (current US$) of Minerals?
Ensure brevity in your answer.  8.46e+07. What is the difference between the highest and the lowest Cost (current US$) of Energy?
Offer a very short reply. 4.21e+08. What is the difference between the highest and the lowest Cost (current US$) in Forest?
Keep it short and to the point. 2.81e+08. 